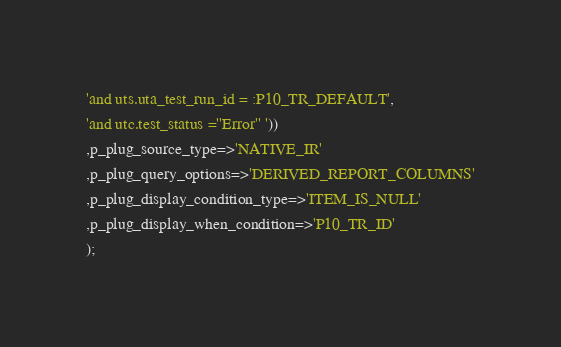<code> <loc_0><loc_0><loc_500><loc_500><_SQL_>'and uts.uta_test_run_id = :P10_TR_DEFAULT',
'and utc.test_status =''Error'' '))
,p_plug_source_type=>'NATIVE_IR'
,p_plug_query_options=>'DERIVED_REPORT_COLUMNS'
,p_plug_display_condition_type=>'ITEM_IS_NULL'
,p_plug_display_when_condition=>'P10_TR_ID'
);</code> 